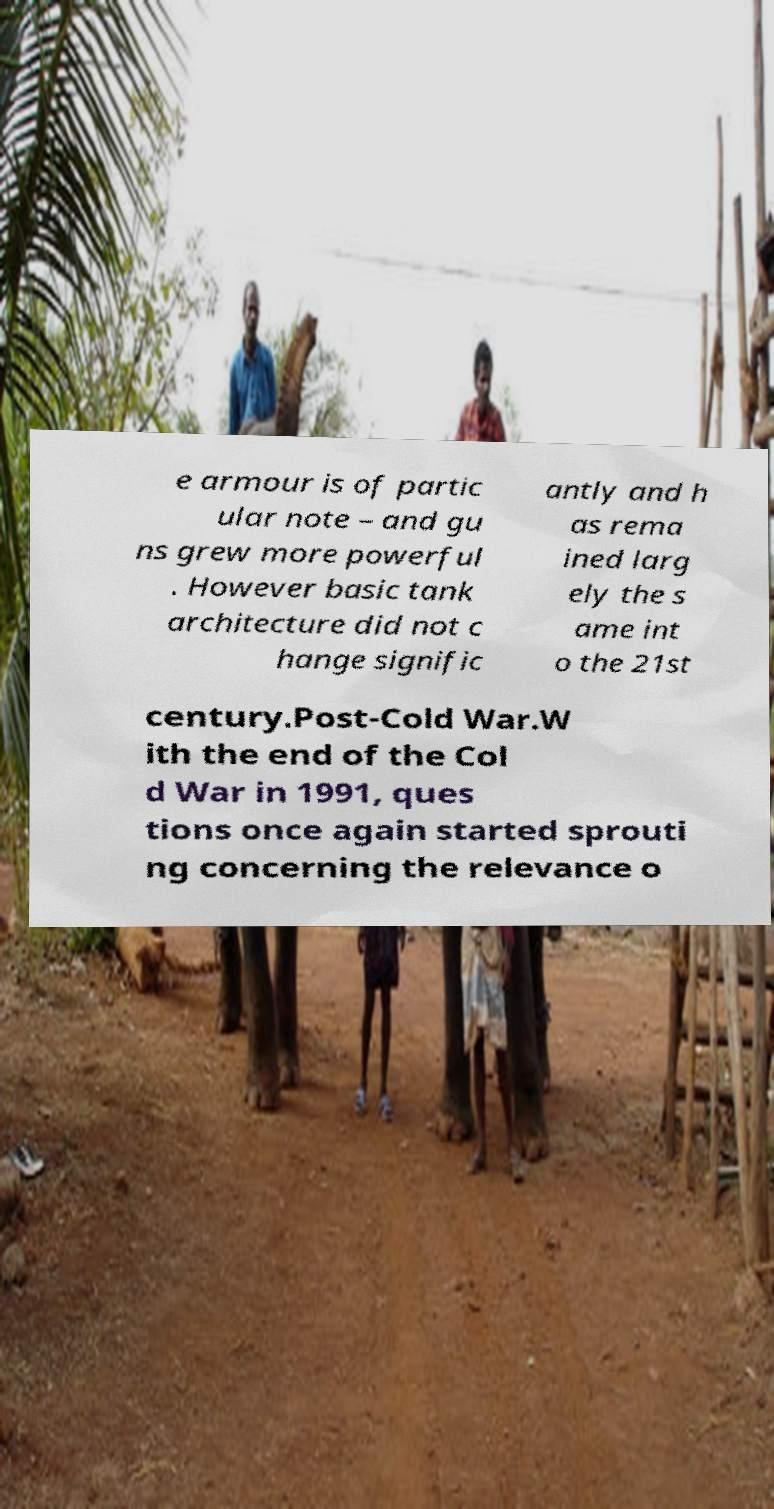Please identify and transcribe the text found in this image. e armour is of partic ular note – and gu ns grew more powerful . However basic tank architecture did not c hange signific antly and h as rema ined larg ely the s ame int o the 21st century.Post-Cold War.W ith the end of the Col d War in 1991, ques tions once again started sprouti ng concerning the relevance o 